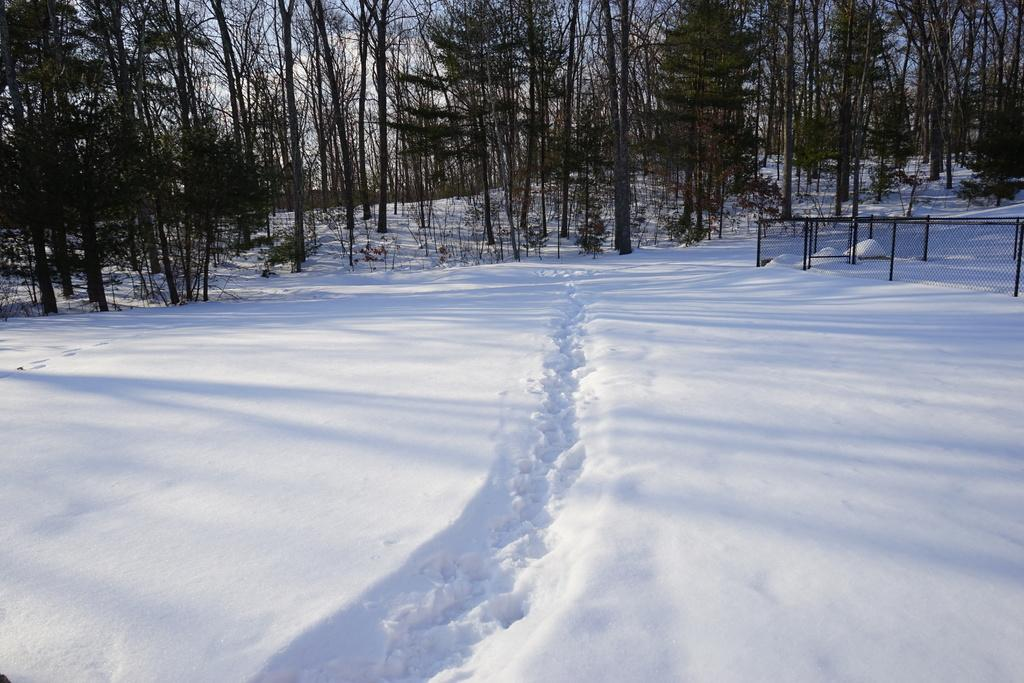What is the predominant weather condition in the image? There is snow in the image, indicating a cold and wintry condition. What type of vegetation can be seen in the image? There are trees at the top of the image. What is the structure on the right side of the image? There is a fence on the right side of the image. What type of needle can be seen in the image? There is no needle present in the image. What type of club is visible in the image? There is no club present in the image. 